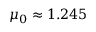Convert formula to latex. <formula><loc_0><loc_0><loc_500><loc_500>\mu _ { 0 } \approx 1 . 2 4 5</formula> 